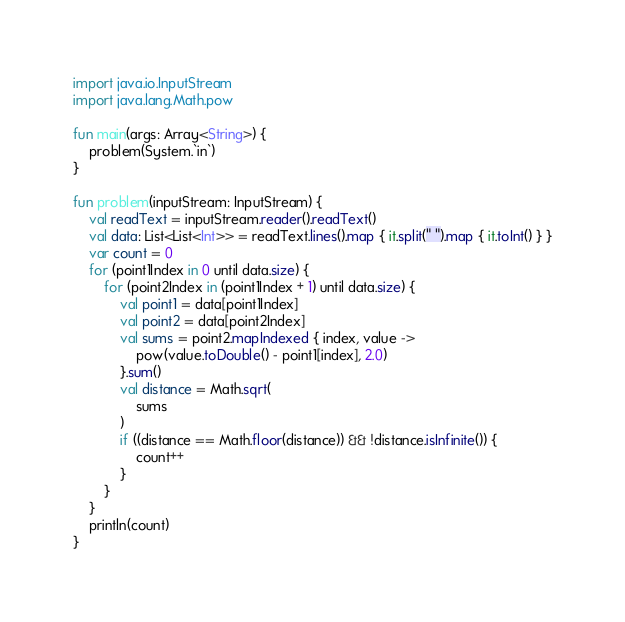<code> <loc_0><loc_0><loc_500><loc_500><_Kotlin_>import java.io.InputStream
import java.lang.Math.pow

fun main(args: Array<String>) {
    problem(System.`in`)
}

fun problem(inputStream: InputStream) {
    val readText = inputStream.reader().readText()
    val data: List<List<Int>> = readText.lines().map { it.split(" ").map { it.toInt() } }
    var count = 0
    for (point1Index in 0 until data.size) {
        for (point2Index in (point1Index + 1) until data.size) {
            val point1 = data[point1Index]
            val point2 = data[point2Index]
            val sums = point2.mapIndexed { index, value ->
                pow(value.toDouble() - point1[index], 2.0)
            }.sum()
            val distance = Math.sqrt(
                sums
            )
            if ((distance == Math.floor(distance)) && !distance.isInfinite()) {
                count++
            }
        }
    }
    println(count)
}
</code> 